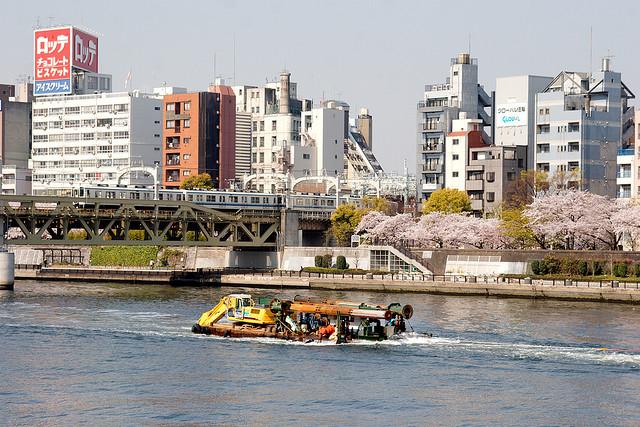What type of boats are shown?
Write a very short answer. Barge. What sort of boat is in the foreground?
Concise answer only. Cargo. Is the writing on the building on the left in English?
Quick response, please. No. Is there an ocean in this pic?
Short answer required. No. Is this picture in America?
Concise answer only. No. 